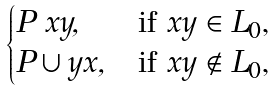Convert formula to latex. <formula><loc_0><loc_0><loc_500><loc_500>\begin{cases} P \ x y , & \text {if $xy\in L_{0}$,} \\ P \cup y x , & \text {if $xy\notin L_{0}$,} \end{cases}</formula> 